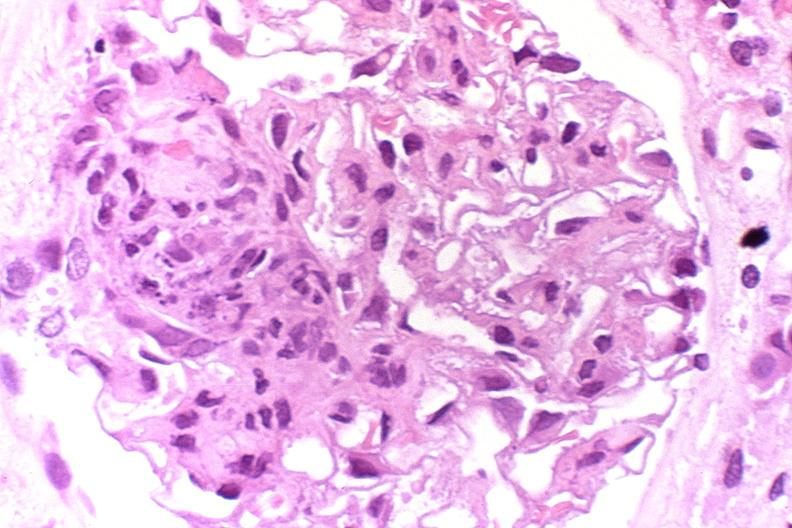what is present?
Answer the question using a single word or phrase. Urinary 